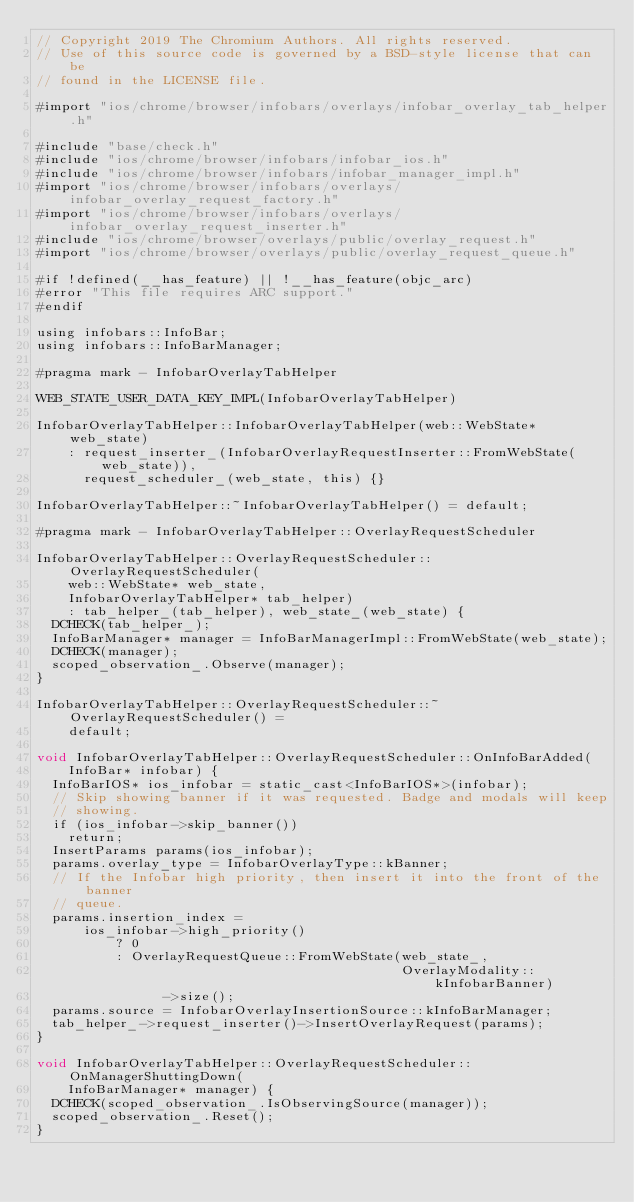Convert code to text. <code><loc_0><loc_0><loc_500><loc_500><_ObjectiveC_>// Copyright 2019 The Chromium Authors. All rights reserved.
// Use of this source code is governed by a BSD-style license that can be
// found in the LICENSE file.

#import "ios/chrome/browser/infobars/overlays/infobar_overlay_tab_helper.h"

#include "base/check.h"
#include "ios/chrome/browser/infobars/infobar_ios.h"
#include "ios/chrome/browser/infobars/infobar_manager_impl.h"
#import "ios/chrome/browser/infobars/overlays/infobar_overlay_request_factory.h"
#import "ios/chrome/browser/infobars/overlays/infobar_overlay_request_inserter.h"
#include "ios/chrome/browser/overlays/public/overlay_request.h"
#import "ios/chrome/browser/overlays/public/overlay_request_queue.h"

#if !defined(__has_feature) || !__has_feature(objc_arc)
#error "This file requires ARC support."
#endif

using infobars::InfoBar;
using infobars::InfoBarManager;

#pragma mark - InfobarOverlayTabHelper

WEB_STATE_USER_DATA_KEY_IMPL(InfobarOverlayTabHelper)

InfobarOverlayTabHelper::InfobarOverlayTabHelper(web::WebState* web_state)
    : request_inserter_(InfobarOverlayRequestInserter::FromWebState(web_state)),
      request_scheduler_(web_state, this) {}

InfobarOverlayTabHelper::~InfobarOverlayTabHelper() = default;

#pragma mark - InfobarOverlayTabHelper::OverlayRequestScheduler

InfobarOverlayTabHelper::OverlayRequestScheduler::OverlayRequestScheduler(
    web::WebState* web_state,
    InfobarOverlayTabHelper* tab_helper)
    : tab_helper_(tab_helper), web_state_(web_state) {
  DCHECK(tab_helper_);
  InfoBarManager* manager = InfoBarManagerImpl::FromWebState(web_state);
  DCHECK(manager);
  scoped_observation_.Observe(manager);
}

InfobarOverlayTabHelper::OverlayRequestScheduler::~OverlayRequestScheduler() =
    default;

void InfobarOverlayTabHelper::OverlayRequestScheduler::OnInfoBarAdded(
    InfoBar* infobar) {
  InfoBarIOS* ios_infobar = static_cast<InfoBarIOS*>(infobar);
  // Skip showing banner if it was requested. Badge and modals will keep
  // showing.
  if (ios_infobar->skip_banner())
    return;
  InsertParams params(ios_infobar);
  params.overlay_type = InfobarOverlayType::kBanner;
  // If the Infobar high priority, then insert it into the front of the banner
  // queue.
  params.insertion_index =
      ios_infobar->high_priority()
          ? 0
          : OverlayRequestQueue::FromWebState(web_state_,
                                              OverlayModality::kInfobarBanner)
                ->size();
  params.source = InfobarOverlayInsertionSource::kInfoBarManager;
  tab_helper_->request_inserter()->InsertOverlayRequest(params);
}

void InfobarOverlayTabHelper::OverlayRequestScheduler::OnManagerShuttingDown(
    InfoBarManager* manager) {
  DCHECK(scoped_observation_.IsObservingSource(manager));
  scoped_observation_.Reset();
}
</code> 